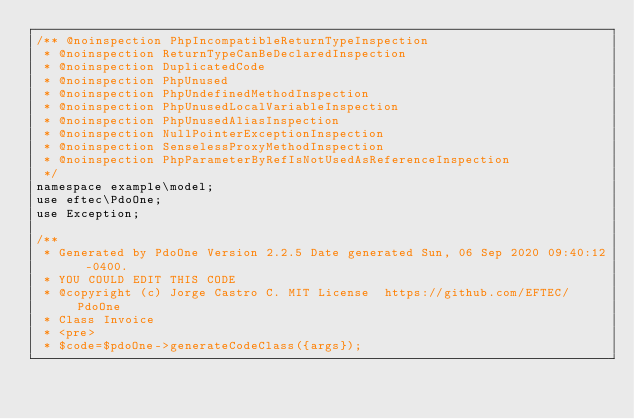Convert code to text. <code><loc_0><loc_0><loc_500><loc_500><_PHP_>/** @noinspection PhpIncompatibleReturnTypeInspection
 * @noinspection ReturnTypeCanBeDeclaredInspection
 * @noinspection DuplicatedCode
 * @noinspection PhpUnused
 * @noinspection PhpUndefinedMethodInspection
 * @noinspection PhpUnusedLocalVariableInspection
 * @noinspection PhpUnusedAliasInspection
 * @noinspection NullPointerExceptionInspection
 * @noinspection SenselessProxyMethodInspection
 * @noinspection PhpParameterByRefIsNotUsedAsReferenceInspection
 */
namespace example\model;
use eftec\PdoOne;
use Exception;

/**
 * Generated by PdoOne Version 2.2.5 Date generated Sun, 06 Sep 2020 09:40:12 -0400. 
 * YOU COULD EDIT THIS CODE
 * @copyright (c) Jorge Castro C. MIT License  https://github.com/EFTEC/PdoOne
 * Class Invoice
 * <pre>
 * $code=$pdoOne->generateCodeClass({args});</code> 